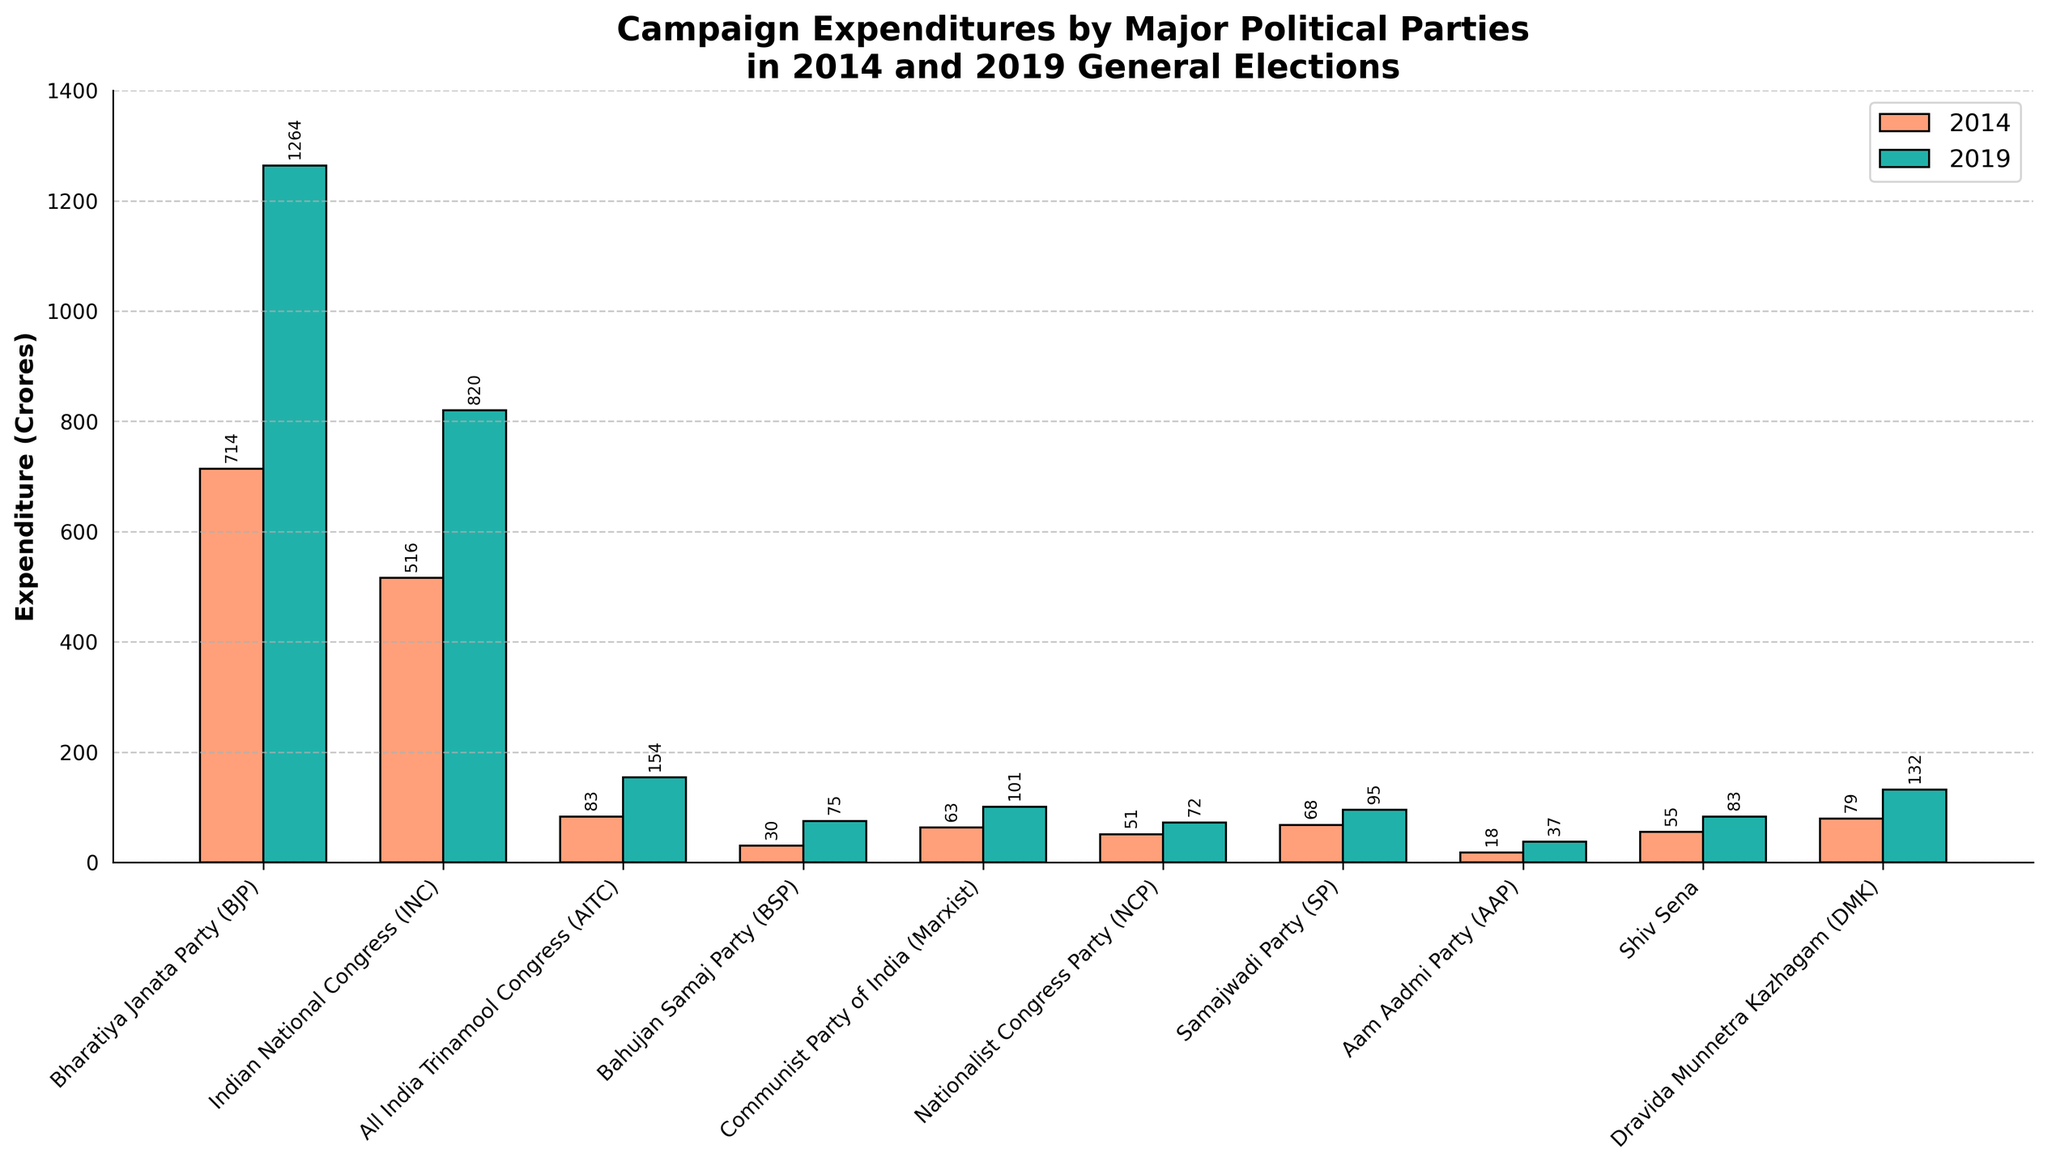What's the total expenditure of BJP and INC in both 2014 and 2019? First, add BJP's expenditures in 2014 (714 crores) and 2019 (1264 crores), then sum INC's expenditures in 2014 (516 crores) and 2019 (820 crores). The overall expenditure is 714 + 1264 + 516 + 820.
Answer: 3314 crores Which party had the smallest increase in expenditure from 2014 to 2019, and by how much? Calculate the increase in expenditure for each party by subtracting their 2014 expenditure from their 2019 expenditure. Compare these values to identify the smallest increase: BSP (75 - 30 = 45 crores).
Answer: BSP, 45 crores By how much did the expenditure of AITC increase from 2014 to 2019? Subtract AITC's expenditure in 2014 (83 crores) from its 2019 expenditure (154 crores): 154 - 83.
Answer: 71 crores In both 2014 and 2019, which party spent the second-highest amount on campaigns? Refer to the bar heights or values for both years. In 2014, the second-highest expenditure was by INC (516 crores). In 2019, INC again had the second-highest expenditure (820 crores).
Answer: INC Which year had higher overall expenditure across all parties, and by how much? Sum up the expenditures for all parties for each year: 2014 (1667 crores) and 2019 (2833 crores). Compare these sums: 2833 - 1667.
Answer: 2019, 1166 crores What's the difference in expenditure between the party with the highest expenditure and the party with the lowest expenditure in 2019? Identify the highest expenditure (BJP - 1264 crores) and the lowest expenditure (AAP - 37 crores) in 2019, and subtract the latter from the former: 1264 - 37.
Answer: 1227 crores What is the average expenditure of all parties in 2019? Sum all expenditures in 2019 (2833 crores) and divide by the number of parties (10): 2833 / 10.
Answer: 283.3 crores Which parties had an expenditure of less than 100 crores in 2014, and how many were they? Identify the parties with expenditures less than 100 crores in 2014: AITC (83 crores), BSP (30 crores), CPI(M) (63 crores), NCP (51 crores), SP (68 crores), AAP (18 crores), Shiv Sena (55 crores), DMK (79 crores). Count these parties.
Answer: 8 parties Which party had the highest percentage increase in expenditure from 2014 to 2019? Calculate the percentage increase for each party: ((2019 expenditure - 2014 expenditure) / 2014 expenditure) * 100. Calculate for all and find the highest percentage: BJP ((1264 - 714) / 714) * 100 ≈ 77.0%.
Answer: BJP 